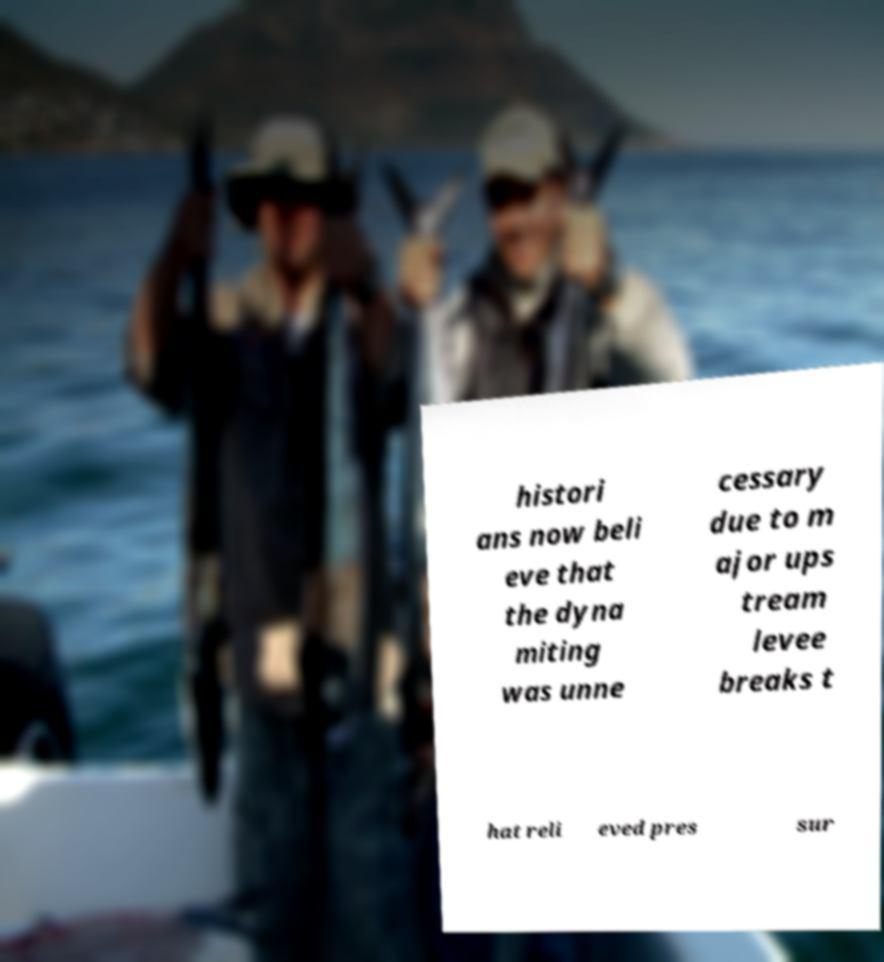For documentation purposes, I need the text within this image transcribed. Could you provide that? histori ans now beli eve that the dyna miting was unne cessary due to m ajor ups tream levee breaks t hat reli eved pres sur 